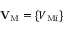Convert formula to latex. <formula><loc_0><loc_0><loc_500><loc_500>{ V } _ { M } = \{ { V _ { { M } i } } \}</formula> 